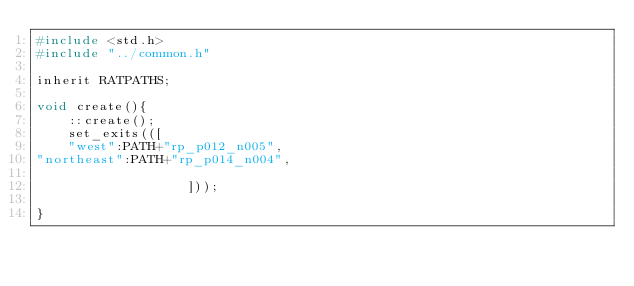Convert code to text. <code><loc_0><loc_0><loc_500><loc_500><_C_>#include <std.h>
#include "../common.h"

inherit RATPATHS;

void create(){
    ::create();
    set_exits(([
    "west":PATH+"rp_p012_n005",
"northeast":PATH+"rp_p014_n004",

                   ]));

}

</code> 